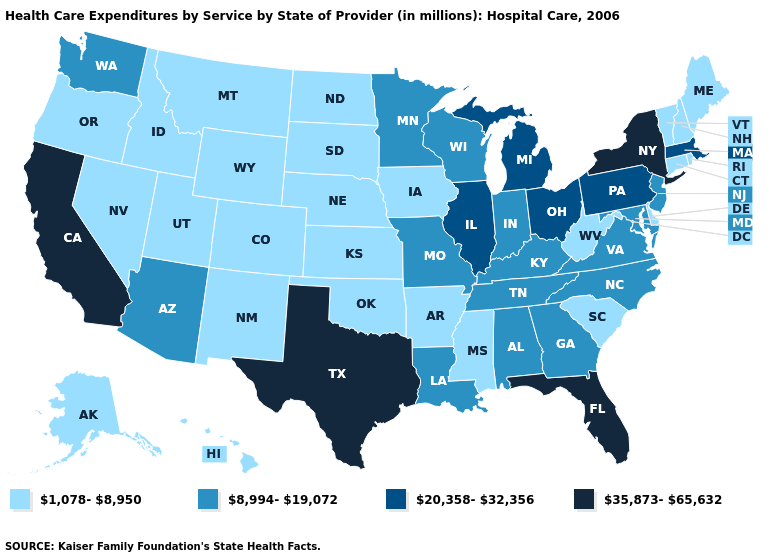What is the value of South Carolina?
Keep it brief. 1,078-8,950. What is the value of Texas?
Short answer required. 35,873-65,632. What is the value of Oklahoma?
Concise answer only. 1,078-8,950. Name the states that have a value in the range 35,873-65,632?
Be succinct. California, Florida, New York, Texas. Among the states that border Tennessee , which have the highest value?
Short answer required. Alabama, Georgia, Kentucky, Missouri, North Carolina, Virginia. Does Texas have the highest value in the USA?
Short answer required. Yes. Which states have the lowest value in the USA?
Quick response, please. Alaska, Arkansas, Colorado, Connecticut, Delaware, Hawaii, Idaho, Iowa, Kansas, Maine, Mississippi, Montana, Nebraska, Nevada, New Hampshire, New Mexico, North Dakota, Oklahoma, Oregon, Rhode Island, South Carolina, South Dakota, Utah, Vermont, West Virginia, Wyoming. How many symbols are there in the legend?
Give a very brief answer. 4. Which states have the lowest value in the MidWest?
Keep it brief. Iowa, Kansas, Nebraska, North Dakota, South Dakota. What is the lowest value in the USA?
Concise answer only. 1,078-8,950. Which states have the lowest value in the MidWest?
Be succinct. Iowa, Kansas, Nebraska, North Dakota, South Dakota. Name the states that have a value in the range 35,873-65,632?
Short answer required. California, Florida, New York, Texas. What is the value of Wisconsin?
Give a very brief answer. 8,994-19,072. Does Hawaii have the lowest value in the West?
Concise answer only. Yes. 